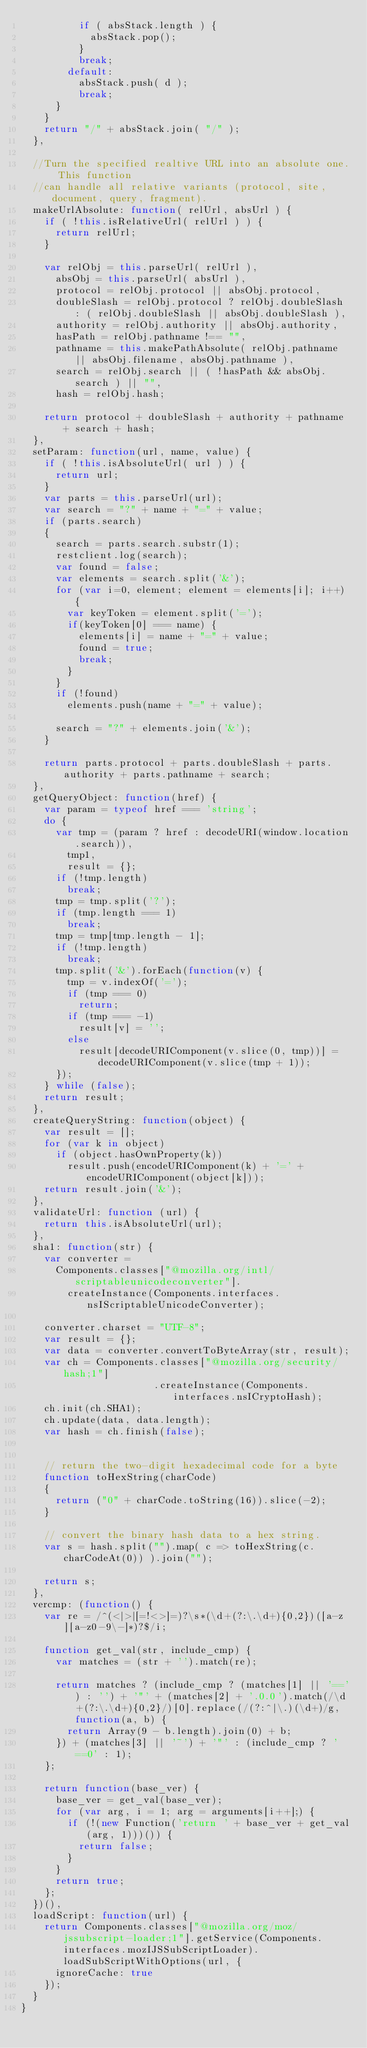Convert code to text. <code><loc_0><loc_0><loc_500><loc_500><_JavaScript_>          if ( absStack.length ) {
            absStack.pop();
          }
          break;
        default:
          absStack.push( d );
          break;
      }
    }
    return "/" + absStack.join( "/" );
  },

  //Turn the specified realtive URL into an absolute one. This function
  //can handle all relative variants (protocol, site, document, query, fragment).
  makeUrlAbsolute: function( relUrl, absUrl ) {
    if ( !this.isRelativeUrl( relUrl ) ) {
      return relUrl;
    }

    var relObj = this.parseUrl( relUrl ),
      absObj = this.parseUrl( absUrl ),
      protocol = relObj.protocol || absObj.protocol,
      doubleSlash = relObj.protocol ? relObj.doubleSlash : ( relObj.doubleSlash || absObj.doubleSlash ),
      authority = relObj.authority || absObj.authority,
      hasPath = relObj.pathname !== "",
      pathname = this.makePathAbsolute( relObj.pathname || absObj.filename, absObj.pathname ),
      search = relObj.search || ( !hasPath && absObj.search ) || "",
      hash = relObj.hash;

    return protocol + doubleSlash + authority + pathname + search + hash;
  },
  setParam: function(url, name, value) {
    if ( !this.isAbsoluteUrl( url ) ) {
      return url;
    }
    var parts = this.parseUrl(url);
    var search = "?" + name + "=" + value;
    if (parts.search)
    {
      search = parts.search.substr(1);
      restclient.log(search);
      var found = false;
      var elements = search.split('&');
      for (var i=0, element; element = elements[i]; i++) {
        var keyToken = element.split('=');
        if(keyToken[0] === name) {
          elements[i] = name + "=" + value;
          found = true;
          break;
        }
      }
      if (!found)
        elements.push(name + "=" + value);
      
      search = "?" + elements.join('&');
    }
    
    return parts.protocol + parts.doubleSlash + parts.authority + parts.pathname + search;
  },
  getQueryObject: function(href) {
    var param = typeof href === 'string';
    do {
      var tmp = (param ? href : decodeURI(window.location.search)),
        tmp1,
        result = {};
      if (!tmp.length)
        break;
      tmp = tmp.split('?');
      if (tmp.length === 1)
        break;
      tmp = tmp[tmp.length - 1];
      if (!tmp.length)
        break;
      tmp.split('&').forEach(function(v) {
        tmp = v.indexOf('=');
        if (tmp === 0)
          return;
        if (tmp === -1)
          result[v] = '';
        else
          result[decodeURIComponent(v.slice(0, tmp))] = decodeURIComponent(v.slice(tmp + 1));
      });
    } while (false);
    return result;
  },
  createQueryString: function(object) {
    var result = [];
    for (var k in object)
      if (object.hasOwnProperty(k))
        result.push(encodeURIComponent(k) + '=' + encodeURIComponent(object[k]));
    return result.join('&');
  },
  validateUrl: function (url) {
    return this.isAbsoluteUrl(url);
  },
  sha1: function(str) {
    var converter =
      Components.classes["@mozilla.org/intl/scriptableunicodeconverter"].
        createInstance(Components.interfaces.nsIScriptableUnicodeConverter);

    converter.charset = "UTF-8";
    var result = {};
    var data = converter.convertToByteArray(str, result);
    var ch = Components.classes["@mozilla.org/security/hash;1"]
                       .createInstance(Components.interfaces.nsICryptoHash);
    ch.init(ch.SHA1);
    ch.update(data, data.length);
    var hash = ch.finish(false);


    // return the two-digit hexadecimal code for a byte
    function toHexString(charCode)
    {
      return ("0" + charCode.toString(16)).slice(-2);
    }

    // convert the binary hash data to a hex string.
    var s = hash.split("").map( c => toHexString(c.charCodeAt(0)) ).join("");

    return s;
  },
  vercmp: (function() {
    var re = /^(<|>|[=!<>]=)?\s*(\d+(?:\.\d+){0,2})([a-z][a-z0-9\-]*)?$/i;

    function get_val(str, include_cmp) {
      var matches = (str + '').match(re);

      return matches ? (include_cmp ? (matches[1] || '==') : '') + '"' + (matches[2] + '.0.0').match(/\d+(?:\.\d+){0,2}/)[0].replace(/(?:^|\.)(\d+)/g, function(a, b) {
        return Array(9 - b.length).join(0) + b;
      }) + (matches[3] || '~') + '"' : (include_cmp ? '==0' : 1);
    };

    return function(base_ver) {
      base_ver = get_val(base_ver);
      for (var arg, i = 1; arg = arguments[i++];) {
        if (!(new Function('return ' + base_ver + get_val(arg, 1)))()) {
          return false;
        }
      }
      return true;
    };
  })(),
  loadScript: function(url) {
    return Components.classes["@mozilla.org/moz/jssubscript-loader;1"].getService(Components.interfaces.mozIJSSubScriptLoader).loadSubScriptWithOptions(url, {
      ignoreCache: true
    });
  }
}
</code> 